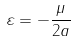Convert formula to latex. <formula><loc_0><loc_0><loc_500><loc_500>\varepsilon = - { \frac { \mu } { 2 a } }</formula> 